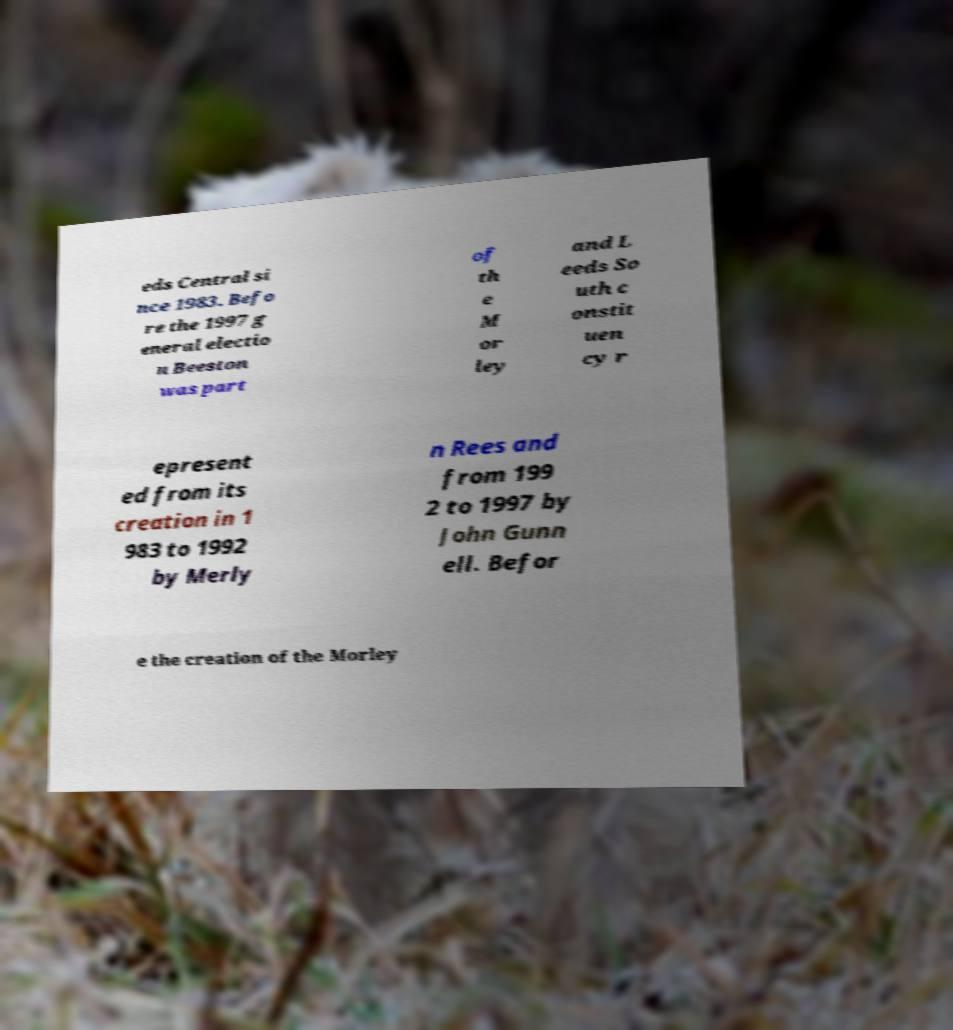Please read and relay the text visible in this image. What does it say? eds Central si nce 1983. Befo re the 1997 g eneral electio n Beeston was part of th e M or ley and L eeds So uth c onstit uen cy r epresent ed from its creation in 1 983 to 1992 by Merly n Rees and from 199 2 to 1997 by John Gunn ell. Befor e the creation of the Morley 